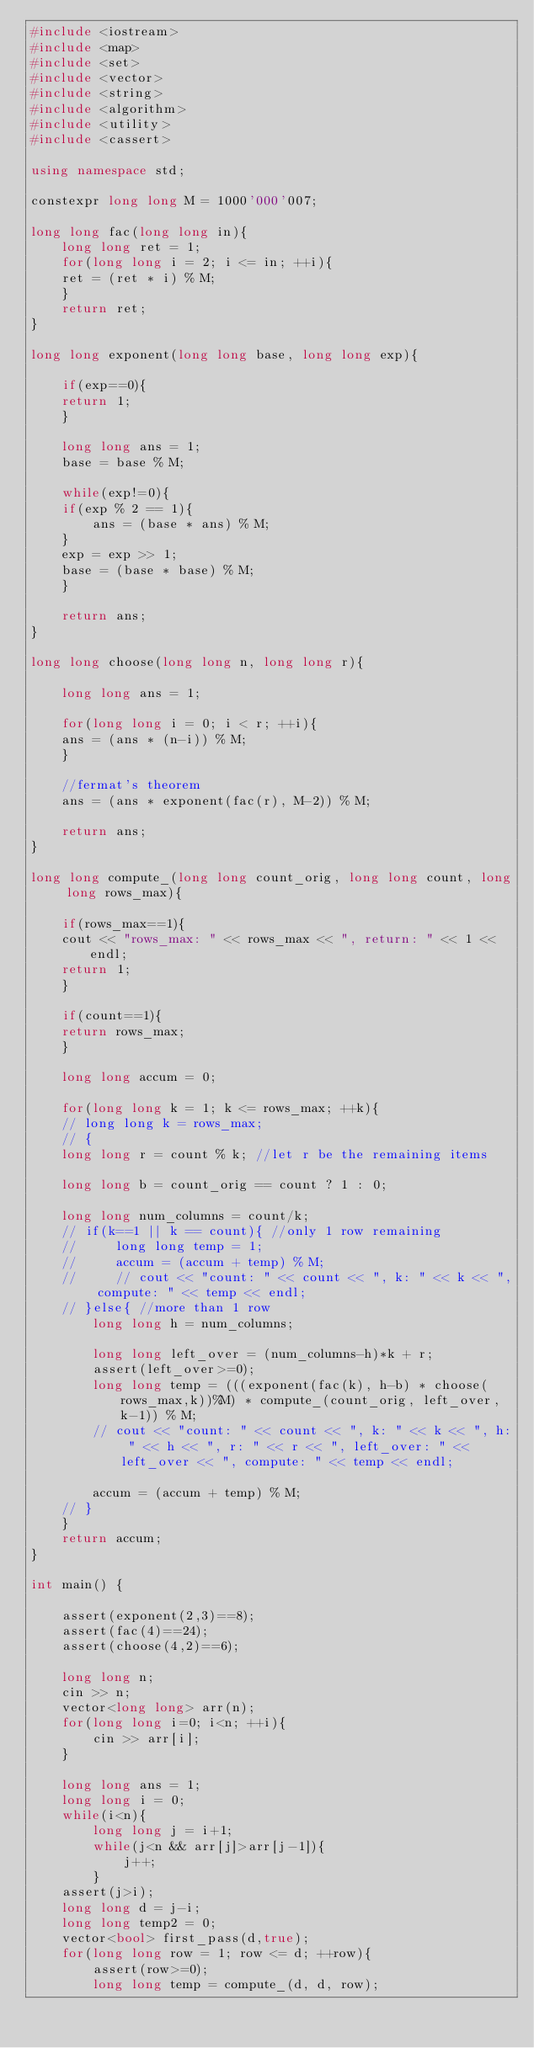<code> <loc_0><loc_0><loc_500><loc_500><_C++_>#include <iostream>
#include <map>
#include <set>
#include <vector>
#include <string>
#include <algorithm>
#include <utility>
#include <cassert>

using namespace std;

constexpr long long M = 1000'000'007;

long long fac(long long in){
    long long ret = 1;
    for(long long i = 2; i <= in; ++i){
	ret = (ret * i) % M;
    }
    return ret;
}

long long exponent(long long base, long long exp){
    
    if(exp==0){
	return 1;
    }
	
    long long ans = 1;
    base = base % M;
    
    while(exp!=0){
	if(exp % 2 == 1){
	    ans = (base * ans) % M;
	}
	exp = exp >> 1;
	base = (base * base) % M;
    }

    return ans;
}

long long choose(long long n, long long r){
    
    long long ans = 1;
    
    for(long long i = 0; i < r; ++i){
	ans = (ans * (n-i)) % M;
    }
    
    //fermat's theorem
    ans = (ans * exponent(fac(r), M-2)) % M;
    
    return ans;
}

long long compute_(long long count_orig, long long count, long long rows_max){
    
    if(rows_max==1){
	cout << "rows_max: " << rows_max << ", return: " << 1 << endl;
	return 1;
    }
    
    if(count==1){
	return rows_max;
    }
    
    long long accum = 0;

    for(long long k = 1; k <= rows_max; ++k){
    // long long k = rows_max;
    // {
	long long r = count % k; //let r be the remaining items

	long long b = count_orig == count ? 1 : 0;
	
	long long num_columns = count/k;
	// if(k==1 || k == count){ //only 1 row remaining
	//     long long temp = 1;
	//     accum = (accum + temp) % M;
	//     // cout << "count: " << count << ", k: " << k << ", compute: " << temp << endl;
	// }else{ //more than 1 row
	    long long h = num_columns;

	    long long left_over = (num_columns-h)*k + r;
	    assert(left_over>=0);
	    long long temp = (((exponent(fac(k), h-b) * choose(rows_max,k))%M) * compute_(count_orig, left_over, k-1)) % M;
	    // cout << "count: " << count << ", k: " << k << ", h: " << h << ", r: " << r << ", left_over: " << left_over << ", compute: " << temp << endl;
	    
	    accum = (accum + temp) % M;
	// }
    }
    return accum;
}

int main() {

    assert(exponent(2,3)==8);
    assert(fac(4)==24);
    assert(choose(4,2)==6);
    
    long long n;
    cin >> n;
    vector<long long> arr(n);
    for(long long i=0; i<n; ++i){
    	cin >> arr[i];
    }

    long long ans = 1;
    long long i = 0;
    while(i<n){
    	long long j = i+1;
    	while(j<n && arr[j]>arr[j-1]){
    	    j++;
    	}
	assert(j>i);
	long long d = j-i;
	long long temp2 = 0;
	vector<bool> first_pass(d,true);
	for(long long row = 1; row <= d; ++row){
	    assert(row>=0);
	    long long temp = compute_(d, d, row);</code> 